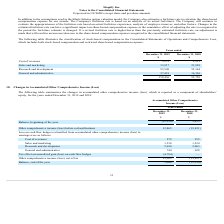According to Shopify's financial document, What information does the table show? the changes in accumulated other comprehensive income (loss), which is reported as a component of shareholders’ equity, for the years ended December 31, 2019 and 2018:. The document states: "The following table summarizes the changes in accumulated other comprehensive income (loss), which is reported as a component of shareholders’ equity,..." Also, What is the accumulated other comprehensive income at the beginning of 2019? According to the financial document, (12,216) (in thousands). The relevant text states: "Balance, beginning of the year (12,216) 3,435..." Also, What is the accumulated other comprehensive income at the beginning of 2018? According to the financial document, 3,435 (in thousands). The relevant text states: "Balance, beginning of the year (12,216) 3,435..." Also, can you calculate: What is the average ending balance of accumulated other comprehensive income for 2018 and 2019? To answer this question, I need to perform calculations using the financial data. The calculation is: [1,046 + (-12,216)] /2, which equals -5585 (in thousands). This is based on the information: "Balance, beginning of the year (12,216) 3,435 Balance, beginning of the year (12,216) 3,435 Balance, end of the year 1,046 (12,216)..." The key data points involved are: 1,046, 12,216, 2. Also, can you calculate: What is the average reclassification of cost of revenues for 2018 and 2019? To answer this question, I need to perform calculations using the financial data. The calculation is: (279+255)/2, which equals 267 (in thousands). This is based on the information: "Cost of revenues 279 255 Cost of revenues 279 255..." The key data points involved are: 255, 279. Also, can you calculate: What is the average reclassification of sales and marketing for 2018 and 2019? To answer this question, I need to perform calculations using the financial data. The calculation is: (1,538+1,224)/2, which equals 1381 (in thousands). This is based on the information: "Sales and marketing 1,538 1,224 Sales and marketing 1,538 1,224..." The key data points involved are: 1,224, 1,538. 